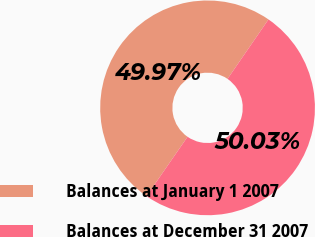Convert chart. <chart><loc_0><loc_0><loc_500><loc_500><pie_chart><fcel>Balances at January 1 2007<fcel>Balances at December 31 2007<nl><fcel>49.97%<fcel>50.03%<nl></chart> 